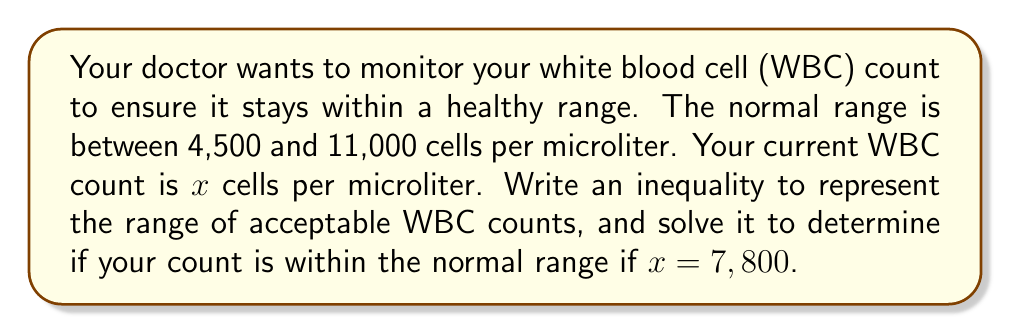Give your solution to this math problem. Let's approach this step-by-step:

1) First, we need to write an inequality that represents the normal range of WBC counts:

   $$4,500 \leq x \leq 11,000$$

   This compound inequality means that $x$ should be greater than or equal to 4,500 and less than or equal to 11,000.

2) Now, we need to check if $x = 7,800$ satisfies this inequality:

   $$4,500 \leq 7,800 \leq 11,000$$

3) Let's check each part of the inequality:
   - Is 7,800 ≥ 4,500? Yes
   - Is 7,800 ≤ 11,000? Yes

4) Since both parts of the inequality are satisfied, we can conclude that 7,800 is within the normal range.
Answer: $7,800$ is within the normal range. 